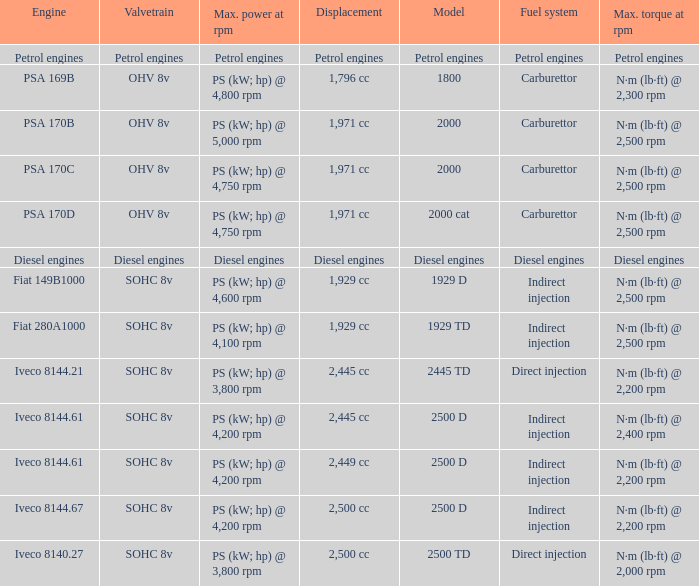What is the maximum torque that has 2,445 CC Displacement, and an Iveco 8144.61 engine? N·m (lb·ft) @ 2,400 rpm. 